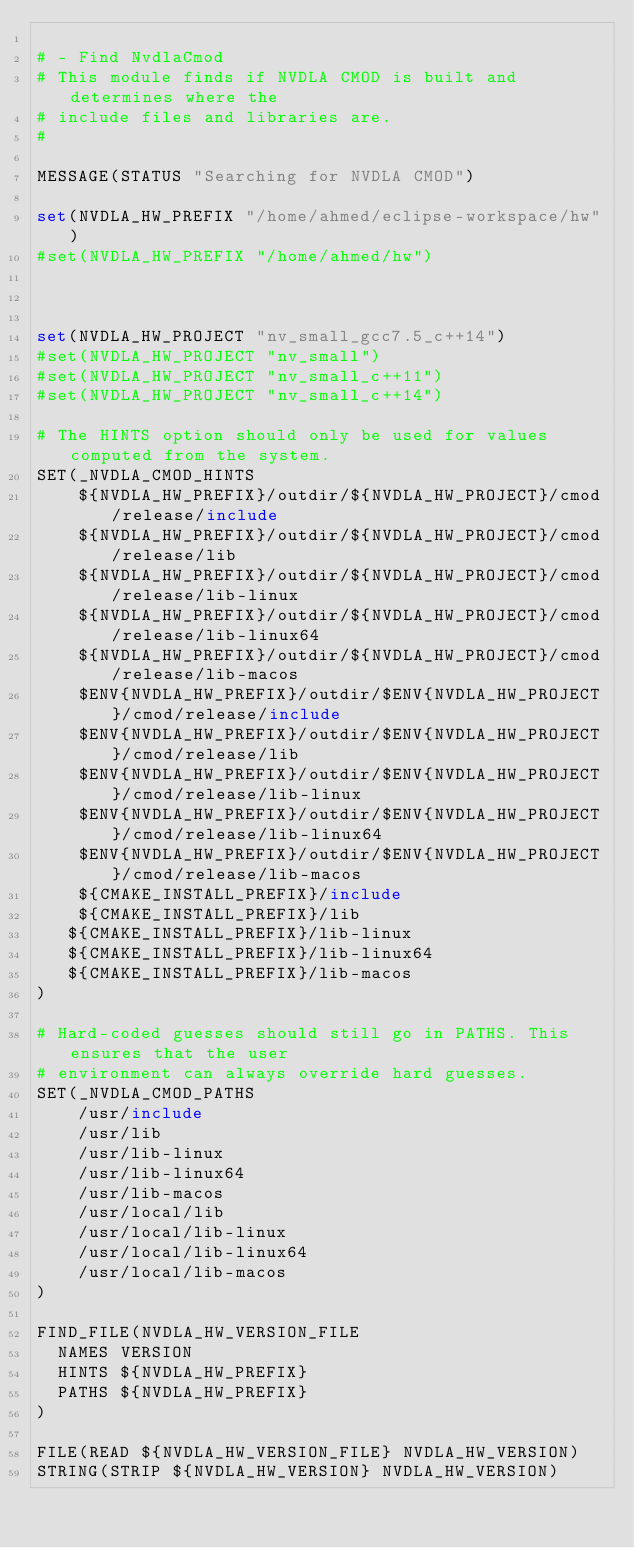<code> <loc_0><loc_0><loc_500><loc_500><_CMake_>
# - Find NvdlaCmod
# This module finds if NVDLA CMOD is built and determines where the
# include files and libraries are.
#

MESSAGE(STATUS "Searching for NVDLA CMOD")

set(NVDLA_HW_PREFIX "/home/ahmed/eclipse-workspace/hw")
#set(NVDLA_HW_PREFIX "/home/ahmed/hw")



set(NVDLA_HW_PROJECT "nv_small_gcc7.5_c++14")
#set(NVDLA_HW_PROJECT "nv_small")
#set(NVDLA_HW_PROJECT "nv_small_c++11")
#set(NVDLA_HW_PROJECT "nv_small_c++14")

# The HINTS option should only be used for values computed from the system.
SET(_NVDLA_CMOD_HINTS
    ${NVDLA_HW_PREFIX}/outdir/${NVDLA_HW_PROJECT}/cmod/release/include
    ${NVDLA_HW_PREFIX}/outdir/${NVDLA_HW_PROJECT}/cmod/release/lib
    ${NVDLA_HW_PREFIX}/outdir/${NVDLA_HW_PROJECT}/cmod/release/lib-linux
    ${NVDLA_HW_PREFIX}/outdir/${NVDLA_HW_PROJECT}/cmod/release/lib-linux64
    ${NVDLA_HW_PREFIX}/outdir/${NVDLA_HW_PROJECT}/cmod/release/lib-macos
    $ENV{NVDLA_HW_PREFIX}/outdir/$ENV{NVDLA_HW_PROJECT}/cmod/release/include
    $ENV{NVDLA_HW_PREFIX}/outdir/$ENV{NVDLA_HW_PROJECT}/cmod/release/lib
    $ENV{NVDLA_HW_PREFIX}/outdir/$ENV{NVDLA_HW_PROJECT}/cmod/release/lib-linux
    $ENV{NVDLA_HW_PREFIX}/outdir/$ENV{NVDLA_HW_PROJECT}/cmod/release/lib-linux64
    $ENV{NVDLA_HW_PREFIX}/outdir/$ENV{NVDLA_HW_PROJECT}/cmod/release/lib-macos
    ${CMAKE_INSTALL_PREFIX}/include
    ${CMAKE_INSTALL_PREFIX}/lib
   ${CMAKE_INSTALL_PREFIX}/lib-linux
   ${CMAKE_INSTALL_PREFIX}/lib-linux64
   ${CMAKE_INSTALL_PREFIX}/lib-macos
)

# Hard-coded guesses should still go in PATHS. This ensures that the user
# environment can always override hard guesses.
SET(_NVDLA_CMOD_PATHS
    /usr/include
    /usr/lib
    /usr/lib-linux
    /usr/lib-linux64
    /usr/lib-macos
    /usr/local/lib
    /usr/local/lib-linux
    /usr/local/lib-linux64
    /usr/local/lib-macos
)

FIND_FILE(NVDLA_HW_VERSION_FILE
  NAMES VERSION
  HINTS ${NVDLA_HW_PREFIX}
  PATHS ${NVDLA_HW_PREFIX}
)

FILE(READ ${NVDLA_HW_VERSION_FILE} NVDLA_HW_VERSION)
STRING(STRIP ${NVDLA_HW_VERSION} NVDLA_HW_VERSION)</code> 